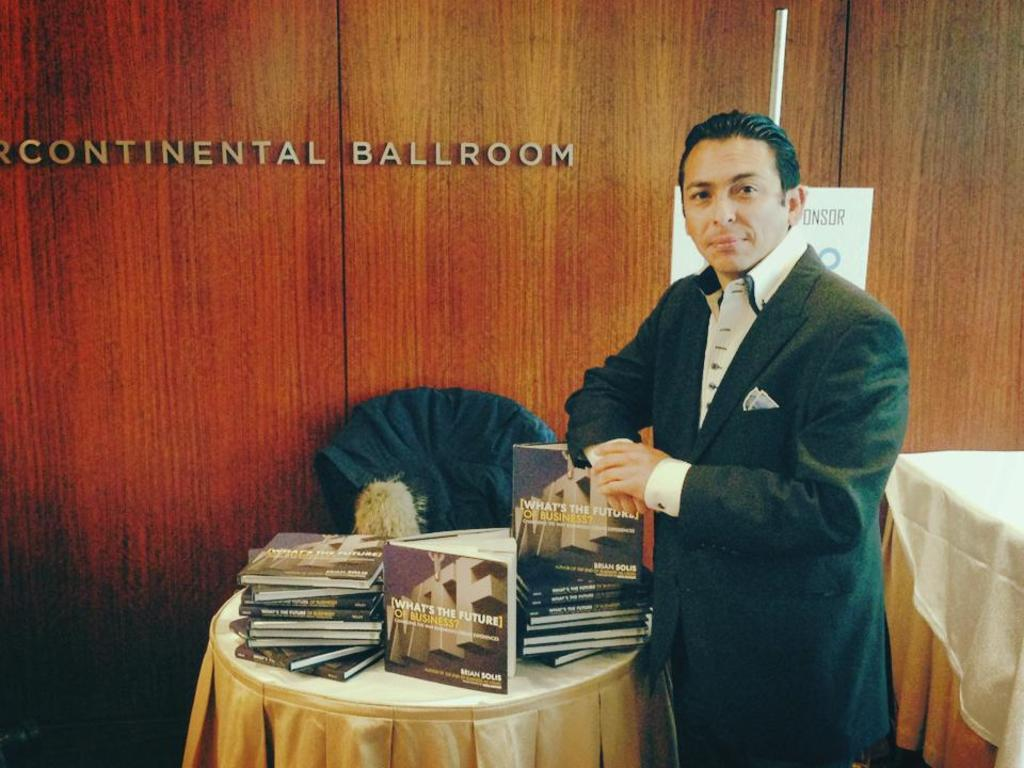<image>
Give a short and clear explanation of the subsequent image. A man in a suit standing next to a table full of books titled "What's The Future of Business?" 